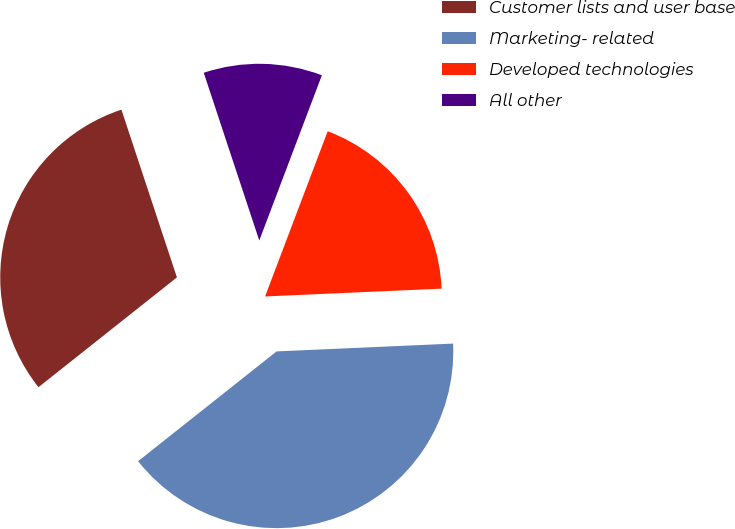<chart> <loc_0><loc_0><loc_500><loc_500><pie_chart><fcel>Customer lists and user base<fcel>Marketing- related<fcel>Developed technologies<fcel>All other<nl><fcel>30.58%<fcel>40.03%<fcel>18.53%<fcel>10.85%<nl></chart> 